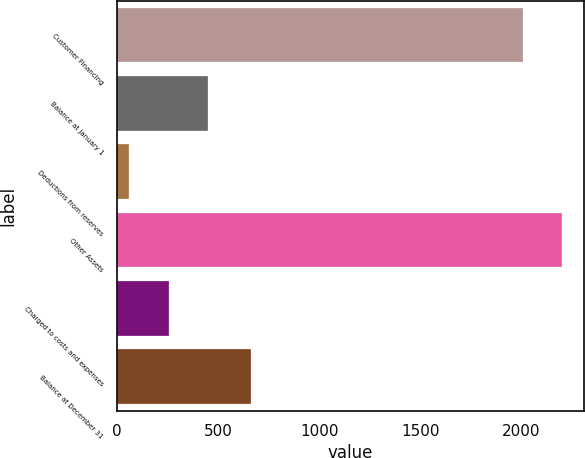Convert chart. <chart><loc_0><loc_0><loc_500><loc_500><bar_chart><fcel>Customer Financing<fcel>Balance at January 1<fcel>Deductions from reserves<fcel>Other Assets<fcel>Charged to costs and expenses<fcel>Balance at December 31<nl><fcel>2007<fcel>448.6<fcel>59<fcel>2201.8<fcel>253.8<fcel>660<nl></chart> 